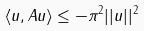<formula> <loc_0><loc_0><loc_500><loc_500>\langle u , A u \rangle \leq - \pi ^ { 2 } | | u | | ^ { 2 }</formula> 